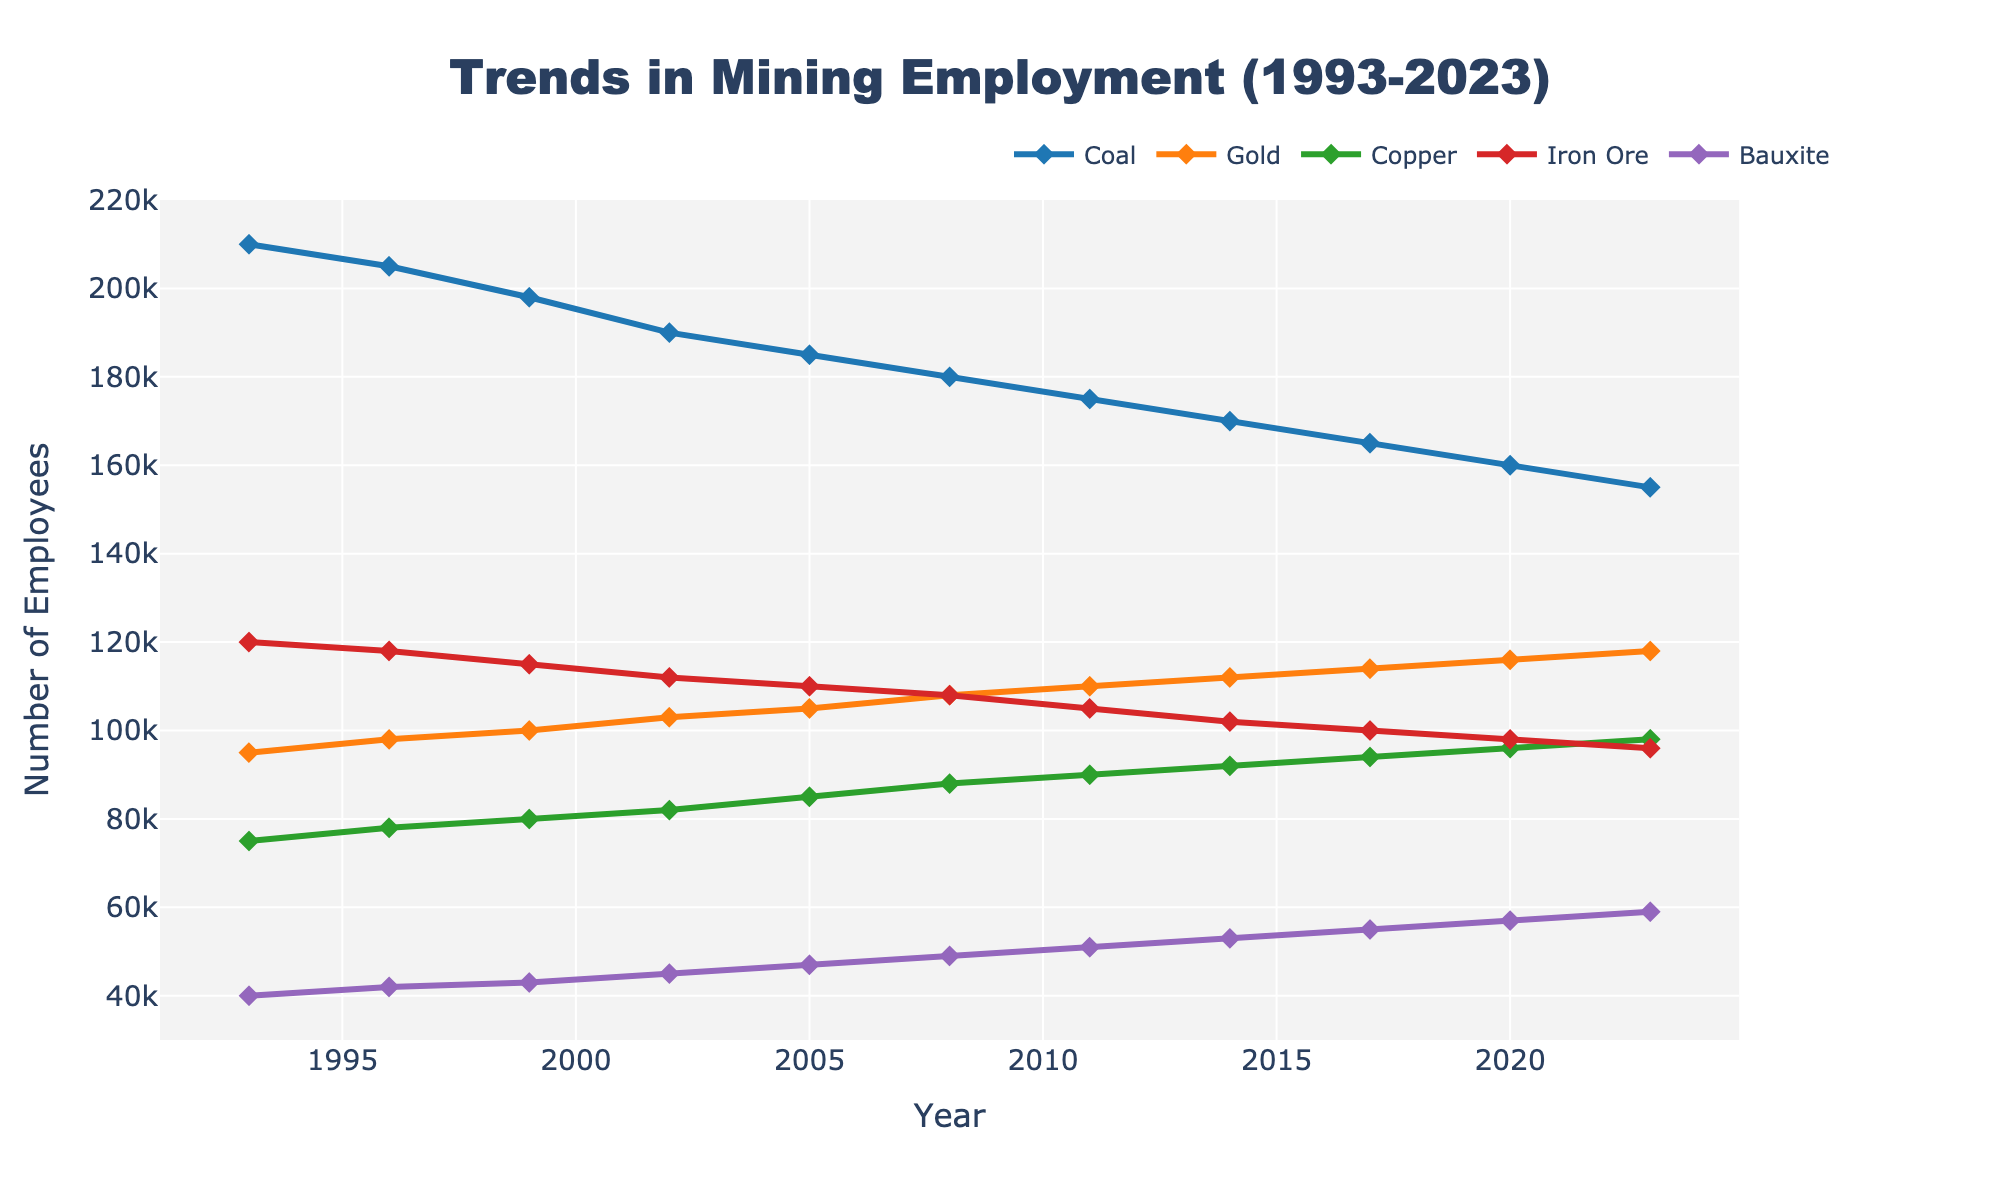What is the overall trend in coal mining employment from 1993 to 2023? To determine the overall trend, look at the endpoints and observe the direction of the line. In 1993, coal mining employment was at 210,000. By 2023, it has decreased to 155,000, indicating a downward trend.
Answer: Downward How does gold mining employment in 2023 compare to coal mining employment in 2023? Look at the values for gold and coal in 2023. Coal employment is at 155,000 and gold is at 118,000. Compare the two numbers.
Answer: Coal is higher Which mineral type has seen the most consistent employment growth over the past 30 years? Examine each line to see which one has consistently increased without major drops. The line for Bauxite has shown steady growth from 40,000 in 1993 to 59,000 in 2023.
Answer: Bauxite In what year did coal mining employment drop below 200,000? Look for the point on the coal line where it first drops below 200,000. This happens between 1999 and 2002. Specifically, it reaches 190,000 in 2002.
Answer: 2002 By how much did copper mining employment increase between 1993 and 2023? Subtract the 1993 copper employment value (75,000) from the 2023 value (98,000). Calculation: 98,000 - 75,000.
Answer: 23,000 Which mineral type had the highest employment in 2008? Look at the different lines for the year 2008 and note the employment values. Coal had 180,000, which is the highest among all.
Answer: Coal Calculate the average employment in iron ore mining over the 30-year period. Sum the iron ore employment values from all the years and divide by the number of years (1993-2023). Calculation: (120,000 + 118,000 + 115,000 + 112,000 + 110,000 + 108,000 + 105,000 + 102,000 + 100,000 + 98,000 + 96,000) / 11.
Answer: 109,636 Which mineral type has shown a decrease in employment from 1993 to 2023? Compare the employment values for each mineral type in 1993 and 2023. Coal has decreased from 210,000 to 155,000 and Iron Ore from 120,000 to 96,000.
Answer: Coal and Iron Ore What is the difference in employment between the highest and lowest mineral types in 2023? Check the employment values for all minerals in 2023 and find the highest (Coal: 155,000) and the lowest (Bauxite: 59,000). Subtract the lowest value from the highest. Calculation: 155,000 - 59,000.
Answer: 96,000 